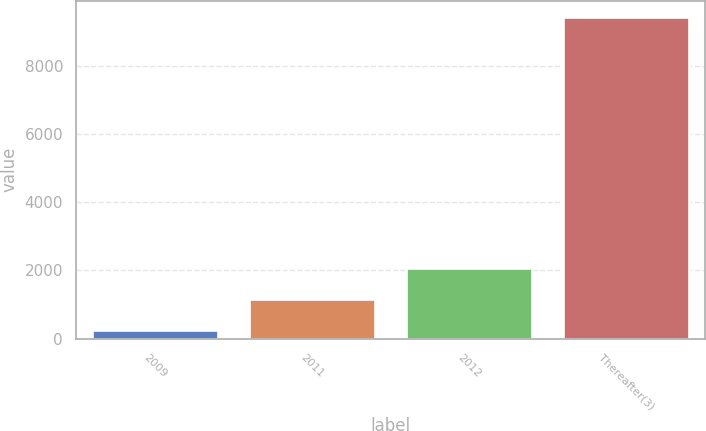<chart> <loc_0><loc_0><loc_500><loc_500><bar_chart><fcel>2009<fcel>2011<fcel>2012<fcel>Thereafter(3)<nl><fcel>250<fcel>1167.9<fcel>2085.8<fcel>9429<nl></chart> 